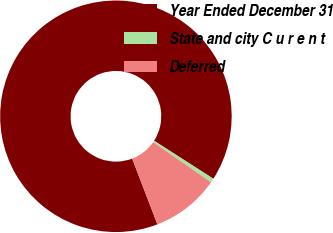Convert chart to OTSL. <chart><loc_0><loc_0><loc_500><loc_500><pie_chart><fcel>Year Ended December 31<fcel>State and city C u r e n t<fcel>Deferred<nl><fcel>89.91%<fcel>0.58%<fcel>9.51%<nl></chart> 